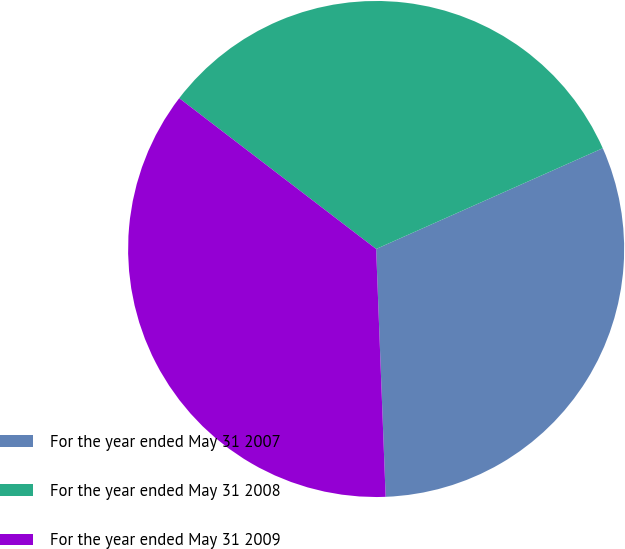Convert chart. <chart><loc_0><loc_0><loc_500><loc_500><pie_chart><fcel>For the year ended May 31 2007<fcel>For the year ended May 31 2008<fcel>For the year ended May 31 2009<nl><fcel>31.05%<fcel>32.94%<fcel>36.01%<nl></chart> 